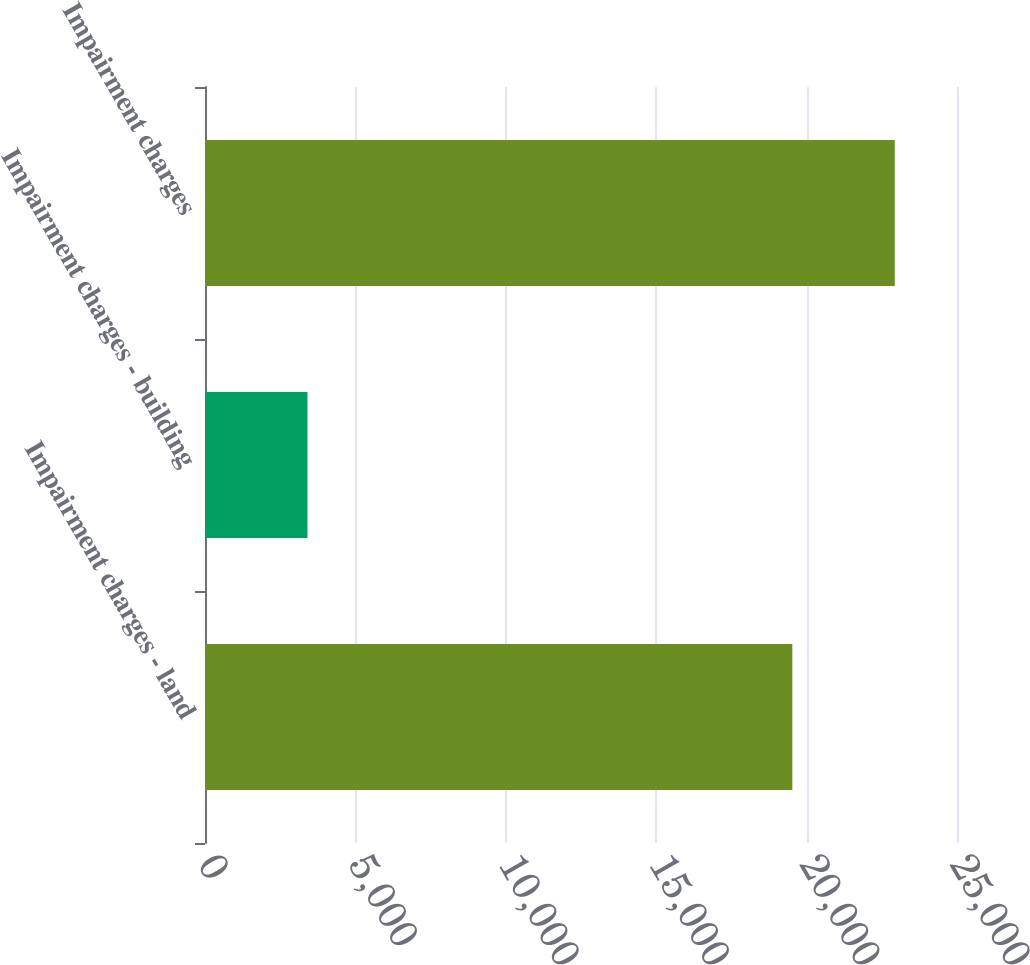Convert chart. <chart><loc_0><loc_0><loc_500><loc_500><bar_chart><fcel>Impairment charges - land<fcel>Impairment charges - building<fcel>Impairment charges<nl><fcel>19526<fcel>3406<fcel>22932<nl></chart> 